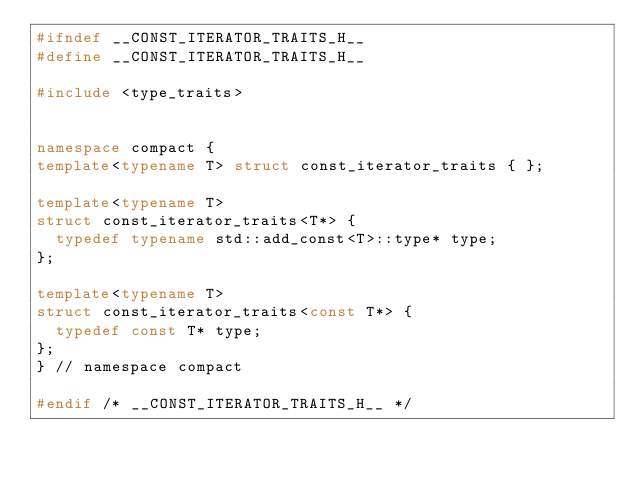<code> <loc_0><loc_0><loc_500><loc_500><_C++_>#ifndef __CONST_ITERATOR_TRAITS_H__
#define __CONST_ITERATOR_TRAITS_H__

#include <type_traits>


namespace compact {
template<typename T> struct const_iterator_traits { };

template<typename T>
struct const_iterator_traits<T*> {
  typedef typename std::add_const<T>::type* type;
};

template<typename T>
struct const_iterator_traits<const T*> {
  typedef const T* type;
};
} // namespace compact

#endif /* __CONST_ITERATOR_TRAITS_H__ */</code> 